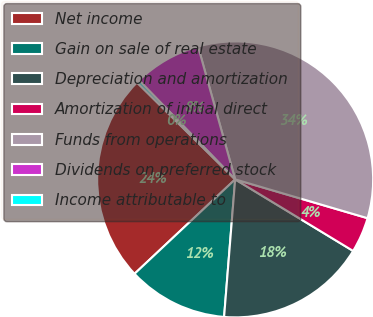Convert chart to OTSL. <chart><loc_0><loc_0><loc_500><loc_500><pie_chart><fcel>Net income<fcel>Gain on sale of real estate<fcel>Depreciation and amortization<fcel>Amortization of initial direct<fcel>Funds from operations<fcel>Dividends on preferred stock<fcel>Income attributable to<nl><fcel>24.39%<fcel>11.73%<fcel>17.6%<fcel>4.14%<fcel>33.87%<fcel>7.93%<fcel>0.34%<nl></chart> 